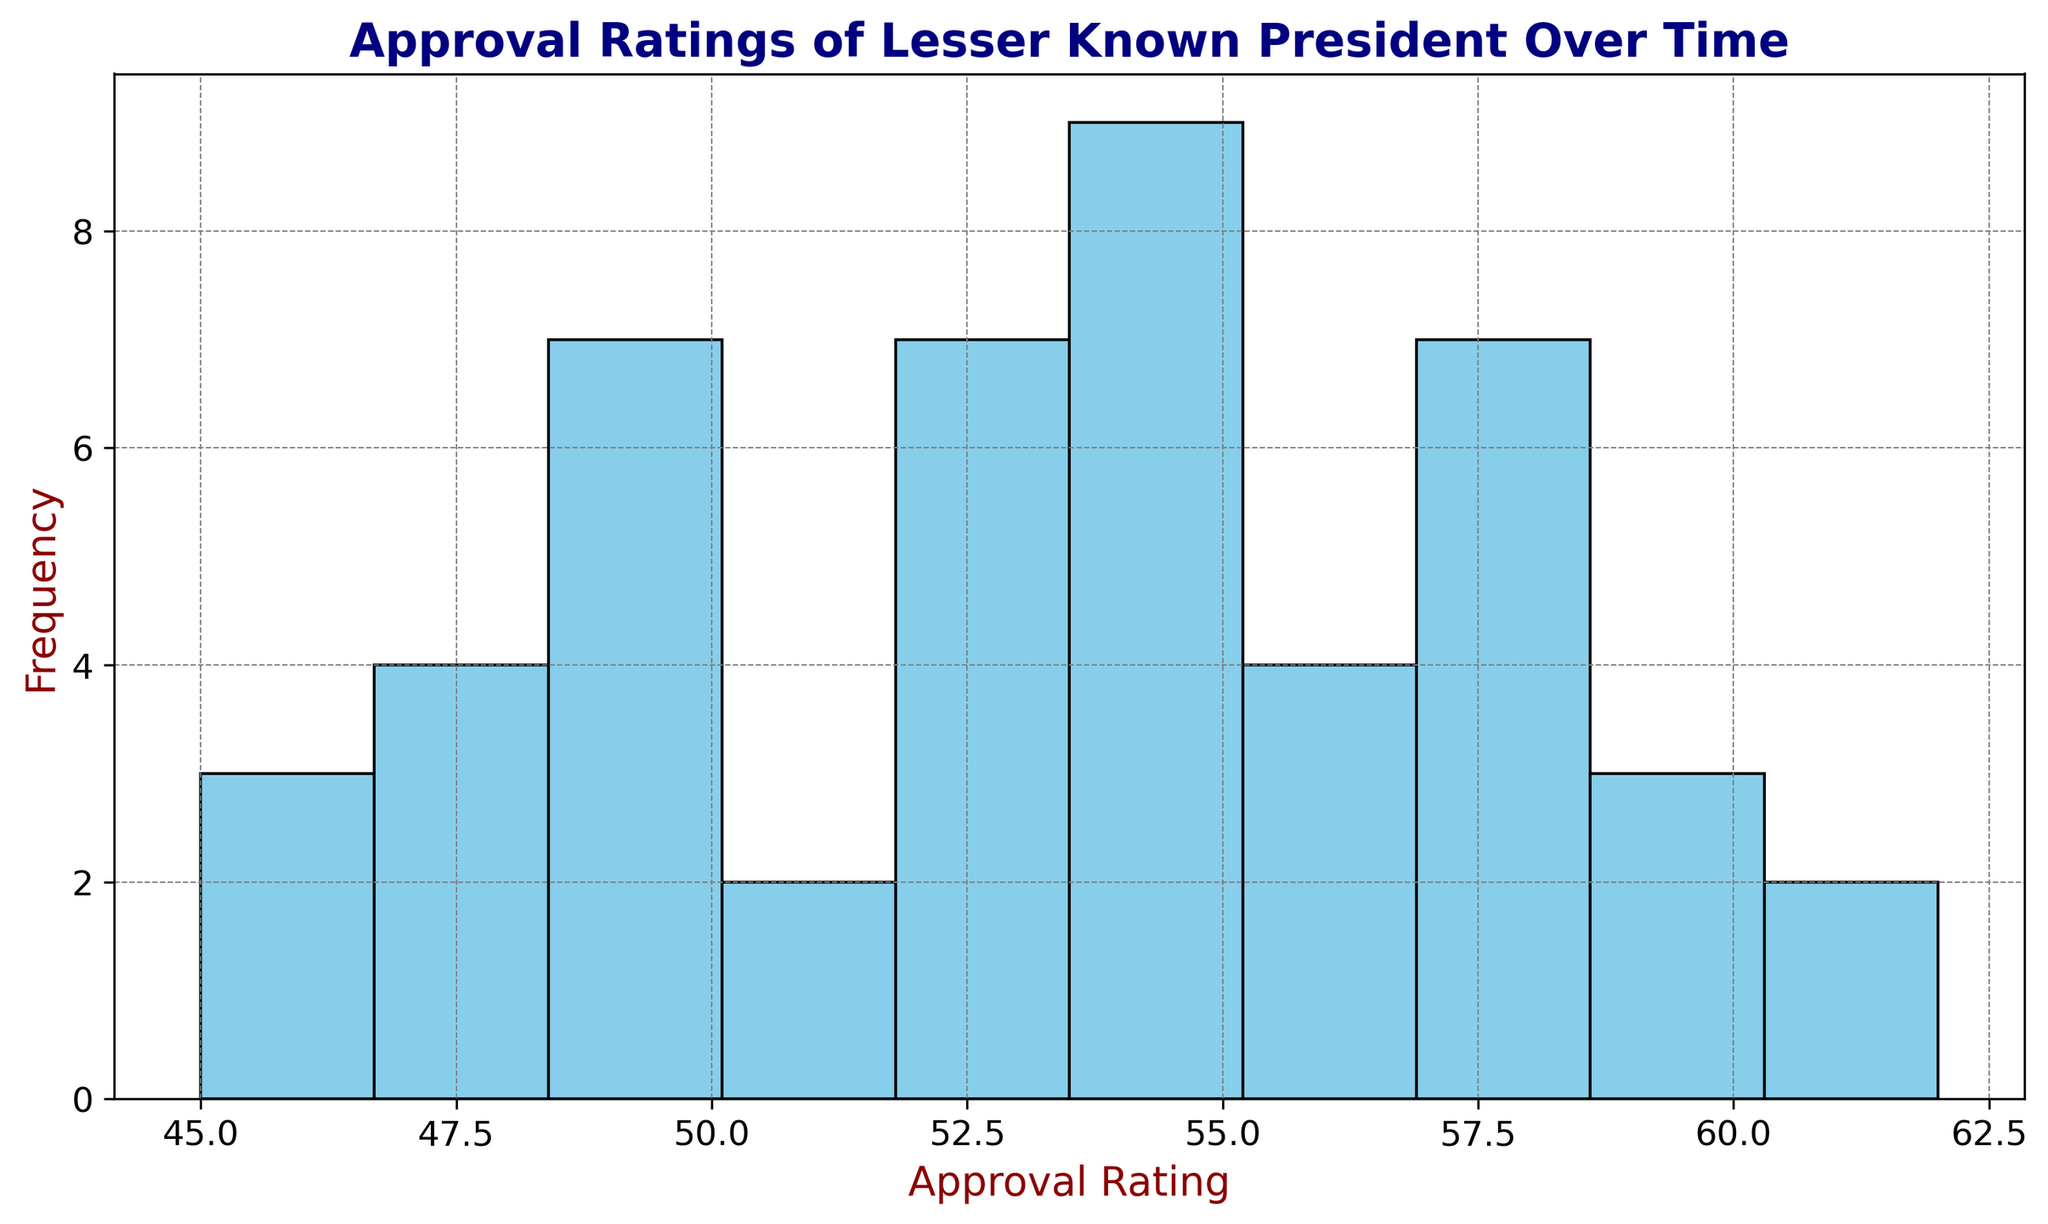what is the most common approval rating range? The most common approval rating range can be identified by looking for the tallest bar in the histogram. The height of the bars indicates the frequency of approval ratings within each range. By observing which bar is the tallest, we can determine the most frequent approval ratings.
Answer: 54-56 How many months have approval ratings between 49 and 51? To find the number of months with approval ratings between 49 and 51, count the frequency of the bar that covers this range. Each bar's height represents the frequency, so by looking at the heights within the specified range, we can determine the count.
Answer: 8 Which approval rating range has the least frequency? To identify the least frequent approval rating range, observe the shortest bar in the histogram. The height of the bars represents the frequency of approval ratings, so the lowest bar indicates the range with the least occurrences.
Answer: 45-47 What is the total number of months with approval ratings above 53? Identify and count all bars representing the ranges with approval ratings greater than 53. Add the frequencies of these bars to find the total number of months with approval ratings above this threshold.
Answer: 19 How does the frequency of approval ratings between 50 and 52 compare to those between 56 and 58? Compare the heights of the bars within the range 50-52 to the heights within the range 56-58. Determine if the frequency within the first range is greater, less, or equal to the second range by comparing the bar heights.
Answer: 50-52 range is more frequent What is the highest approval rating observed, and how many times does it occur? Identify the uppermost range of the histogram and count the frequency associated with this range. The highest approval rating will be the upper limit of this range, and the frequency of occurrences is given by the height of the corresponding bar.
Answer: 62, 1 What is the median approval rating range? The median value is found by ordering the approval ratings and selecting the middle value. Given the histogram, estimate the range containing the middlemost values by counting frequencies until reaching the midpoint of the data set.
Answer: 54-56 What approval rating range would be considered the average if you were to approximate based on visual inspection? Visually approximate which range appears to be centered around the middle of the plotted approval ratings, balancing lower and higher approval rating frequencies. The bar that seems most central represents the average range.
Answer: 54-56 How do approval ratings in Year 1 compare with ratings in Year 4? While exact month-to-month comparisons are not shown in a histogram, observe any general trends about the frequency and height of bars reflecting approval ratings from Year 1 to Year 4. Considering broader ranges and general rising or falling trends may help.
Answer: Year 4 is generally higher What is the cumulative frequency of approval ratings between 48 and 52? Identify and sum the frequencies of all bars covering ranges from 48 to 52. This requires adding the heights of the bars within this range to determine the total or cumulative frequency.
Answer: 14 